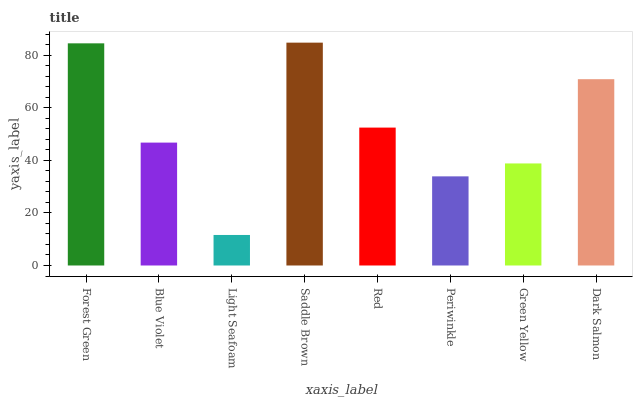Is Light Seafoam the minimum?
Answer yes or no. Yes. Is Saddle Brown the maximum?
Answer yes or no. Yes. Is Blue Violet the minimum?
Answer yes or no. No. Is Blue Violet the maximum?
Answer yes or no. No. Is Forest Green greater than Blue Violet?
Answer yes or no. Yes. Is Blue Violet less than Forest Green?
Answer yes or no. Yes. Is Blue Violet greater than Forest Green?
Answer yes or no. No. Is Forest Green less than Blue Violet?
Answer yes or no. No. Is Red the high median?
Answer yes or no. Yes. Is Blue Violet the low median?
Answer yes or no. Yes. Is Saddle Brown the high median?
Answer yes or no. No. Is Periwinkle the low median?
Answer yes or no. No. 